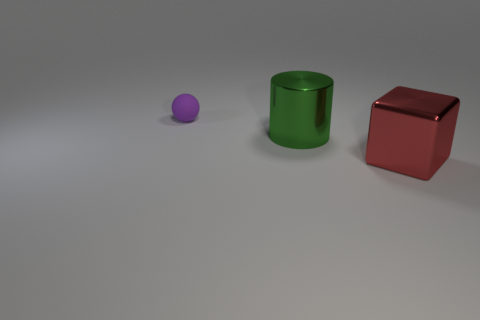Can you tell me what time of day it might be based on the lighting in the scene? It is difficult to determine the time of day based solely on the lighting within the image as it appears to be an indoor scene with artificial lighting. The shadows are soft and the light is evenly distributed, suggesting a controlled lighting environment, likely from an overhead source. 